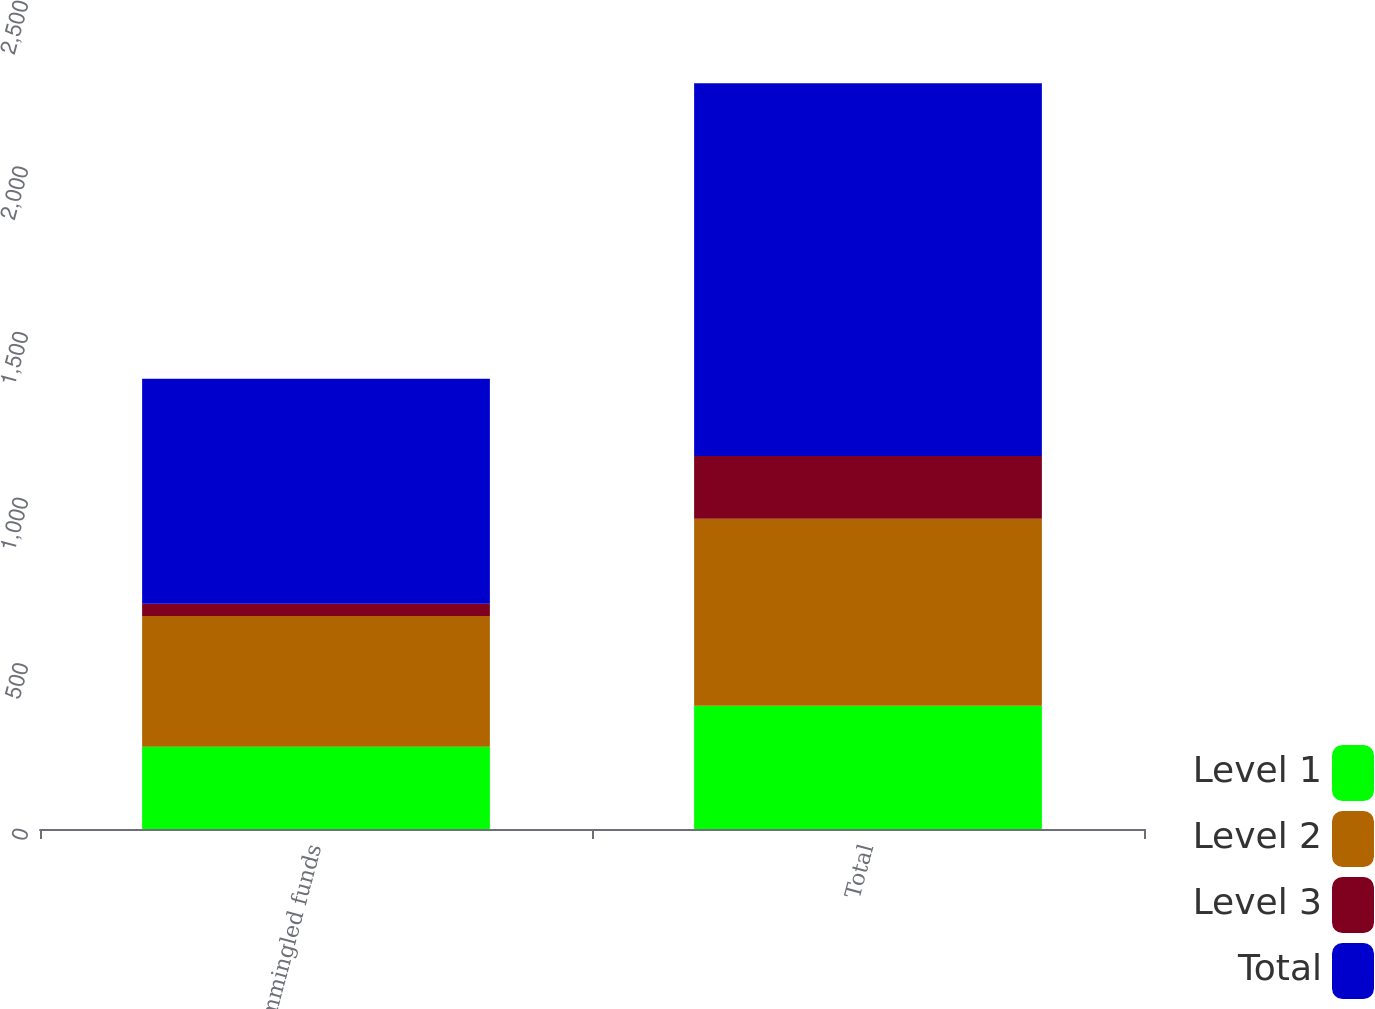Convert chart. <chart><loc_0><loc_0><loc_500><loc_500><stacked_bar_chart><ecel><fcel>Commingled funds<fcel>Total<nl><fcel>Level 1<fcel>248.6<fcel>371.9<nl><fcel>Level 2<fcel>394.6<fcel>564.7<nl><fcel>Level 3<fcel>36.6<fcel>189.4<nl><fcel>Total<fcel>679.8<fcel>1126<nl></chart> 